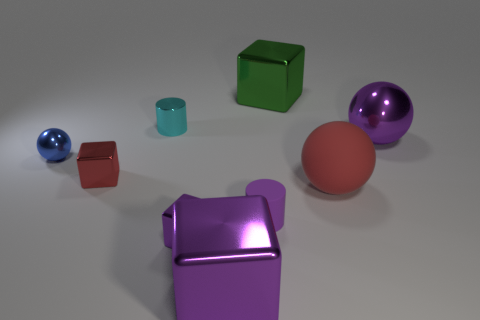Subtract 1 blocks. How many blocks are left? 3 Add 1 big cylinders. How many objects exist? 10 Subtract all blocks. How many objects are left? 5 Subtract all gray rubber balls. Subtract all big rubber spheres. How many objects are left? 8 Add 4 red matte balls. How many red matte balls are left? 5 Add 9 tiny red spheres. How many tiny red spheres exist? 9 Subtract 0 brown balls. How many objects are left? 9 